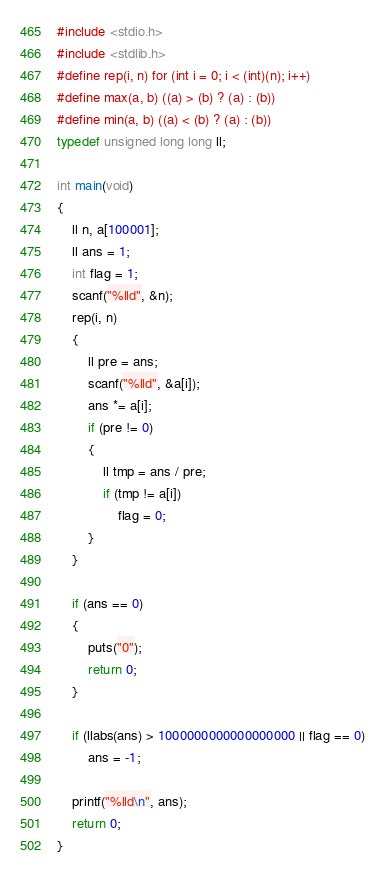Convert code to text. <code><loc_0><loc_0><loc_500><loc_500><_C_>#include <stdio.h>
#include <stdlib.h>
#define rep(i, n) for (int i = 0; i < (int)(n); i++)
#define max(a, b) ((a) > (b) ? (a) : (b))
#define min(a, b) ((a) < (b) ? (a) : (b))
typedef unsigned long long ll;

int main(void)
{
    ll n, a[100001];
    ll ans = 1;
    int flag = 1;
    scanf("%lld", &n);
    rep(i, n)
    {
        ll pre = ans;
        scanf("%lld", &a[i]);
        ans *= a[i];
        if (pre != 0)
        {
            ll tmp = ans / pre;
            if (tmp != a[i])
                flag = 0;
        }
    }

    if (ans == 0)
    {
        puts("0");
        return 0;
    }

    if (llabs(ans) > 1000000000000000000 || flag == 0)
        ans = -1;

    printf("%lld\n", ans);
    return 0;
}</code> 